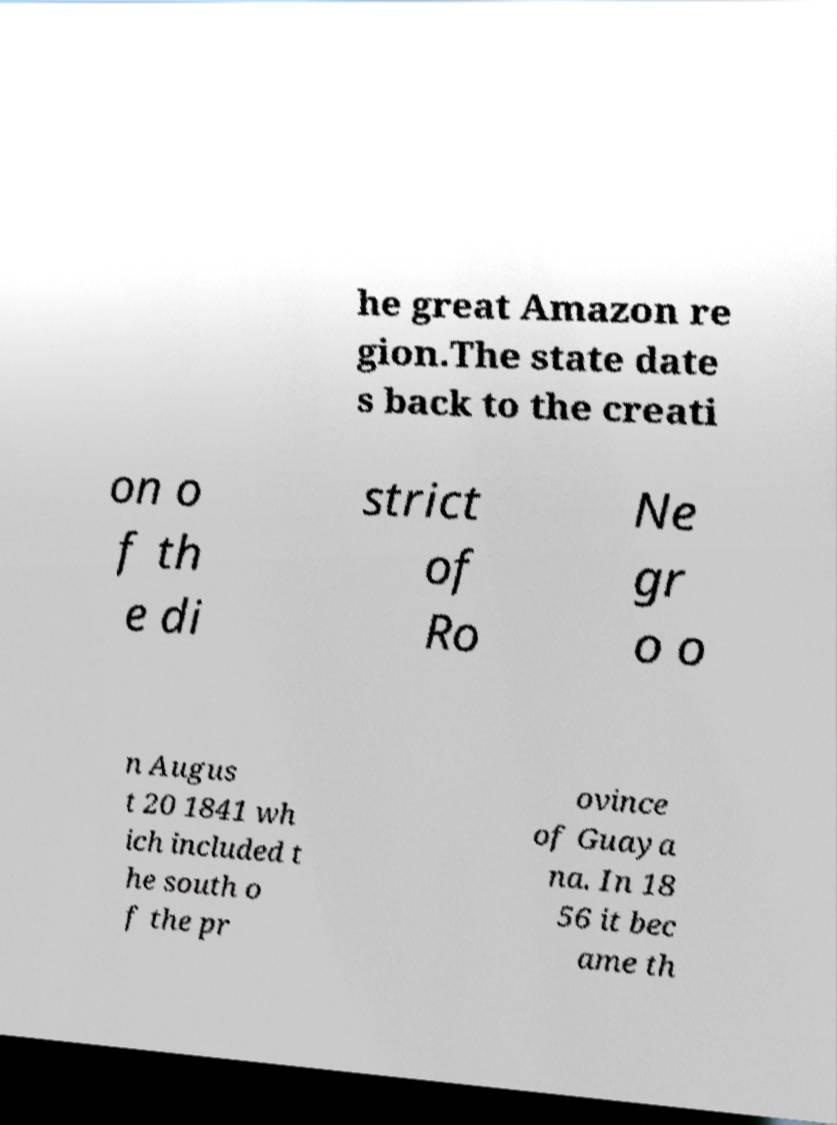Can you accurately transcribe the text from the provided image for me? he great Amazon re gion.The state date s back to the creati on o f th e di strict of Ro Ne gr o o n Augus t 20 1841 wh ich included t he south o f the pr ovince of Guaya na. In 18 56 it bec ame th 